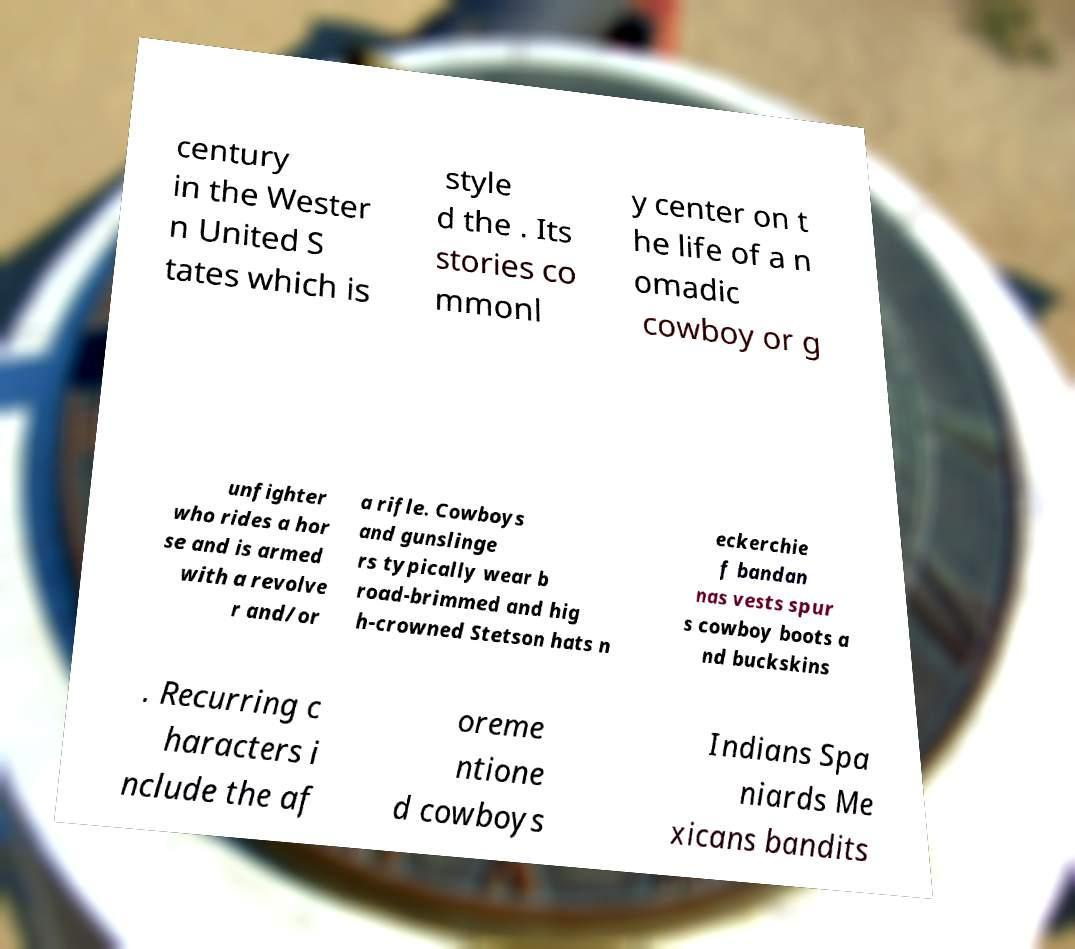Can you accurately transcribe the text from the provided image for me? century in the Wester n United S tates which is style d the . Its stories co mmonl y center on t he life of a n omadic cowboy or g unfighter who rides a hor se and is armed with a revolve r and/or a rifle. Cowboys and gunslinge rs typically wear b road-brimmed and hig h-crowned Stetson hats n eckerchie f bandan nas vests spur s cowboy boots a nd buckskins . Recurring c haracters i nclude the af oreme ntione d cowboys Indians Spa niards Me xicans bandits 